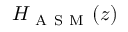Convert formula to latex. <formula><loc_0><loc_0><loc_500><loc_500>H _ { A S M } ( z )</formula> 